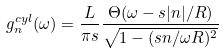Convert formula to latex. <formula><loc_0><loc_0><loc_500><loc_500>g ^ { c y l } _ { n } ( \omega ) = \frac { L } { \pi s } \frac { \Theta ( \omega - s | n | / R ) } { \sqrt { 1 - ( s n / \omega R ) ^ { 2 } } }</formula> 